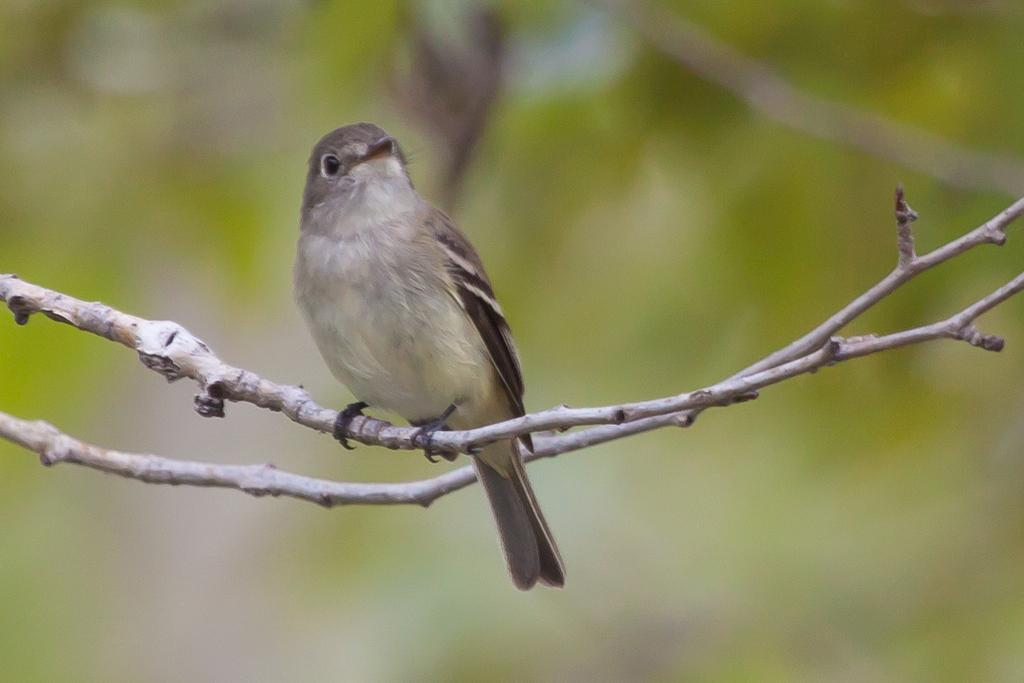What type of animal can be seen in the image? There is a bird in the image. Where is the bird located in the image? The bird is on a stem in the image. Are there any other stems visible in the image? Yes, there is another stem in the image. How would you describe the background of the image? The background of the image is blurry. How does the team increase the ice production in the image? There is no team or ice production present in the image; it features a bird on a stem with another stem in the background. 